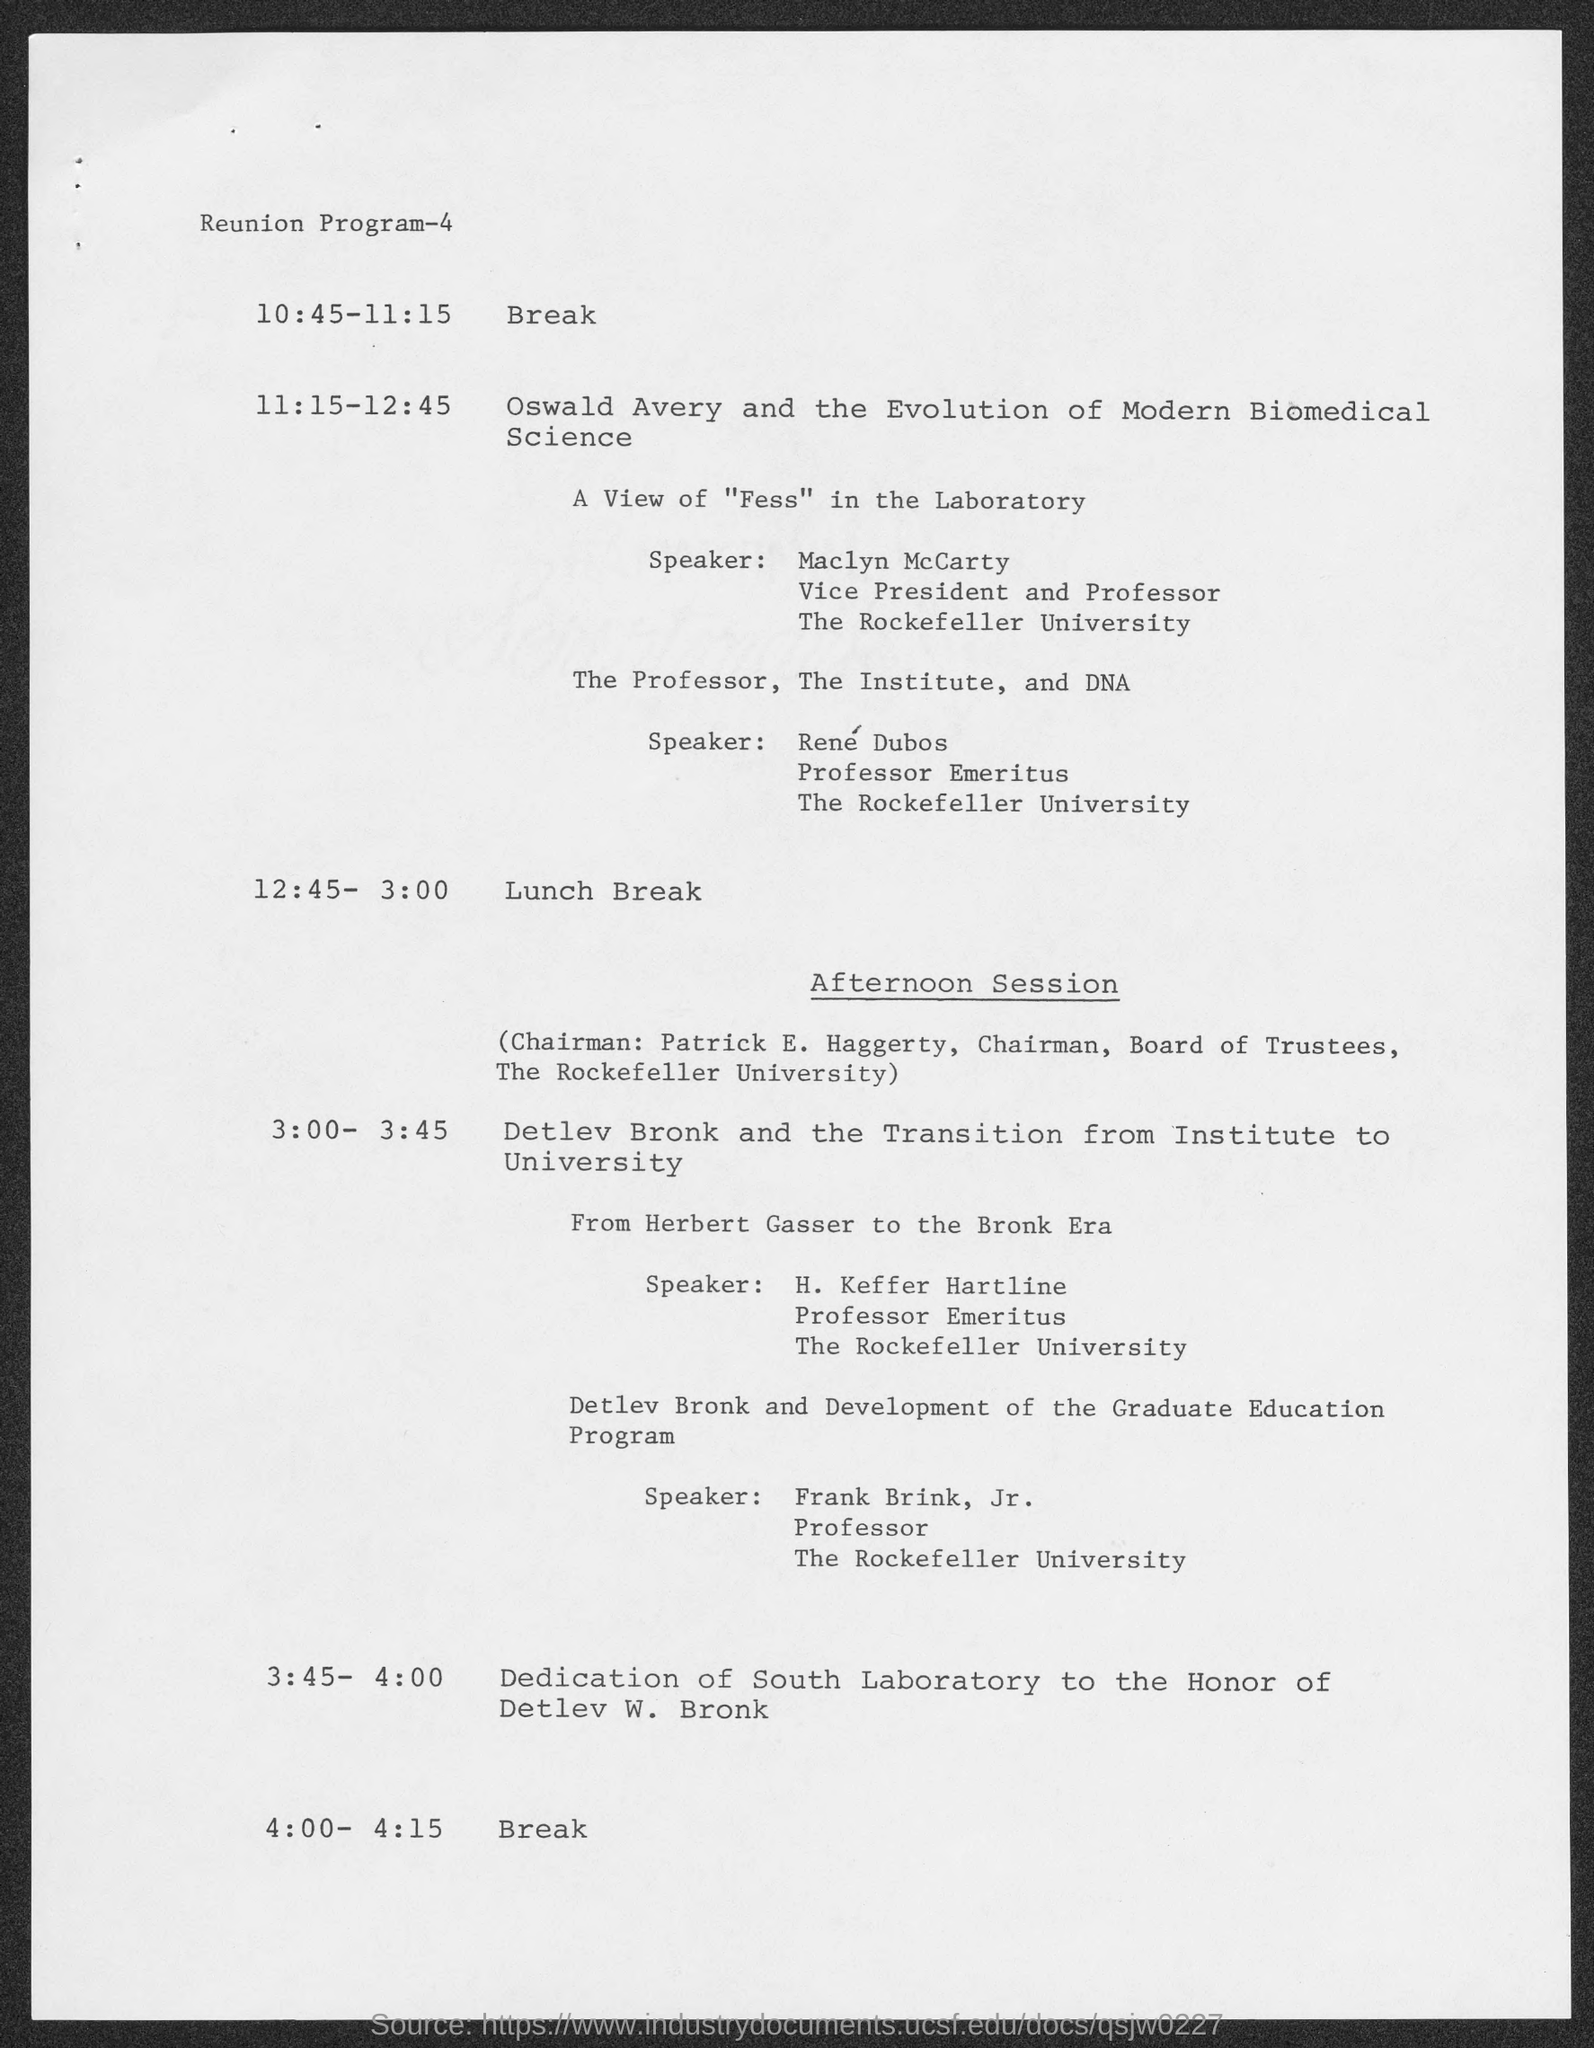Indicate a few pertinent items in this graphic. The speaker in "A view of the laboratory" is Maclyn McCarty. Maclyn McCarty is a member of The Rockefeller University. 